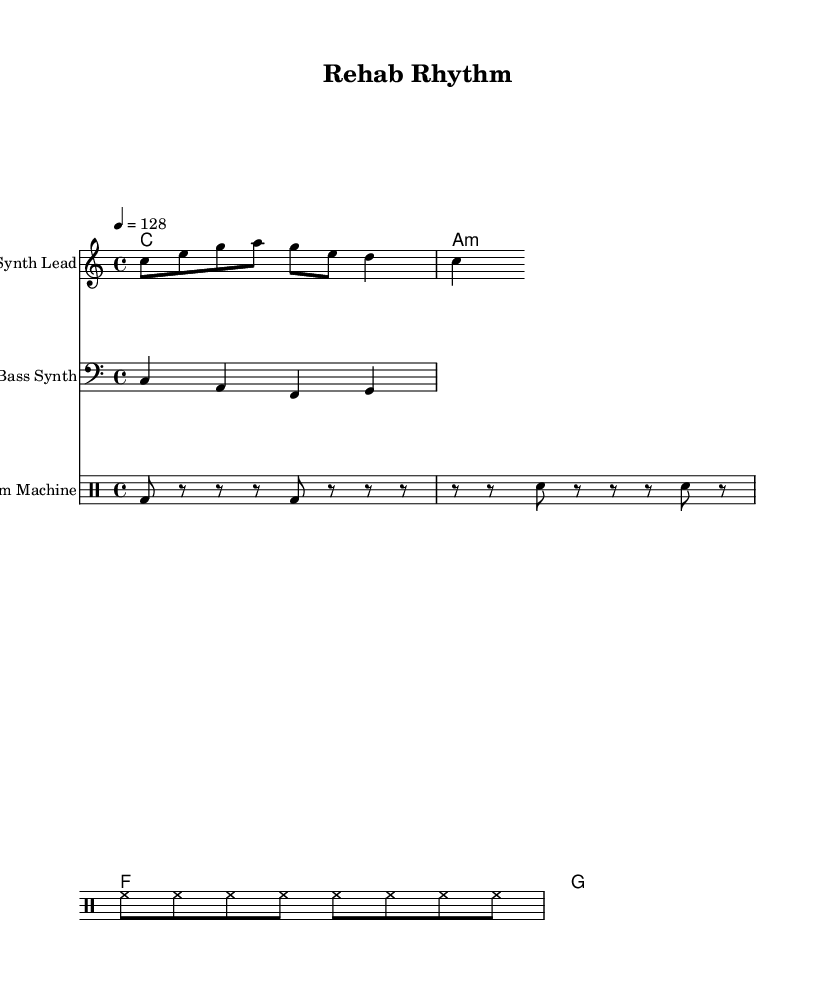What is the key signature of this music? The key signature is C major, which has no sharps or flats.
Answer: C major What is the time signature of this music? The time signature is indicated in the code as 4/4, which means there are 4 beats per measure.
Answer: 4/4 What is the tempo marking of this piece? The tempo marking tells us that the piece is set to a speed of 128 beats per minute. This is indicated by the tempo directive in the code.
Answer: 128 How many measures are there in the melody? The melody contains 8 notes or events within the rhythm pattern, which is represented as one measure with a total of 8 beats due to the 4/4 time signature.
Answer: 1 measure What type of instrument is indicated for the melody? The melody is labeled for a "Synth Lead," which is typically used in electronic music for lead parts and melodies. This is noted in the staff section of the code.
Answer: Synth Lead Is there a drum pattern included? Yes, a drum pattern is present, as specified by the "Drum Machine" instrument in the score, capturing the rhythmic elements of the electronic genre.
Answer: Yes What is the root chord of the first measure in harmony? The first measure in the harmony section shows a root chord of C major, as indicated by the chord symbol.
Answer: C 